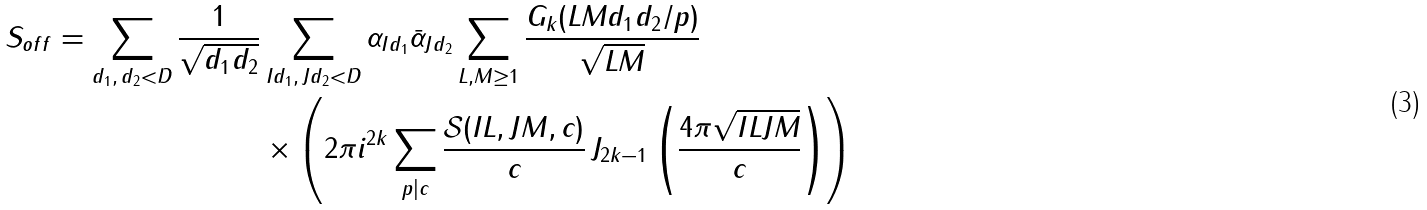<formula> <loc_0><loc_0><loc_500><loc_500>S _ { o f f } = \sum _ { d _ { 1 } , \, d _ { 2 } < D } \frac { 1 } { \sqrt { d _ { 1 } d _ { 2 } } } & \sum _ { I d _ { 1 } , \, J d _ { 2 } < D } \alpha _ { I d _ { 1 } } \bar { \alpha } _ { J d _ { 2 } } \sum _ { L , M \geq 1 } \frac { G _ { k } ( L M d _ { 1 } d _ { 2 } \slash p ) } { \sqrt { L M } } \\ & \times \left ( 2 \pi i ^ { 2 k } \sum _ { p | c } \frac { \mathcal { S } ( I L , J M , c ) } { c } \, J _ { 2 k - 1 } \left ( \frac { 4 \pi \sqrt { I L J M } } { c } \right ) \right )</formula> 